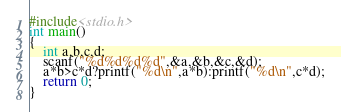Convert code to text. <code><loc_0><loc_0><loc_500><loc_500><_C_>#include<stdio.h>
int main()
{
    int a,b,c,d;
    scanf("%d%d%d%d",&a,&b,&c,&d);
    a*b>c*d?printf("%d\n",a*b):printf("%d\n",c*d);
    return 0;
}</code> 